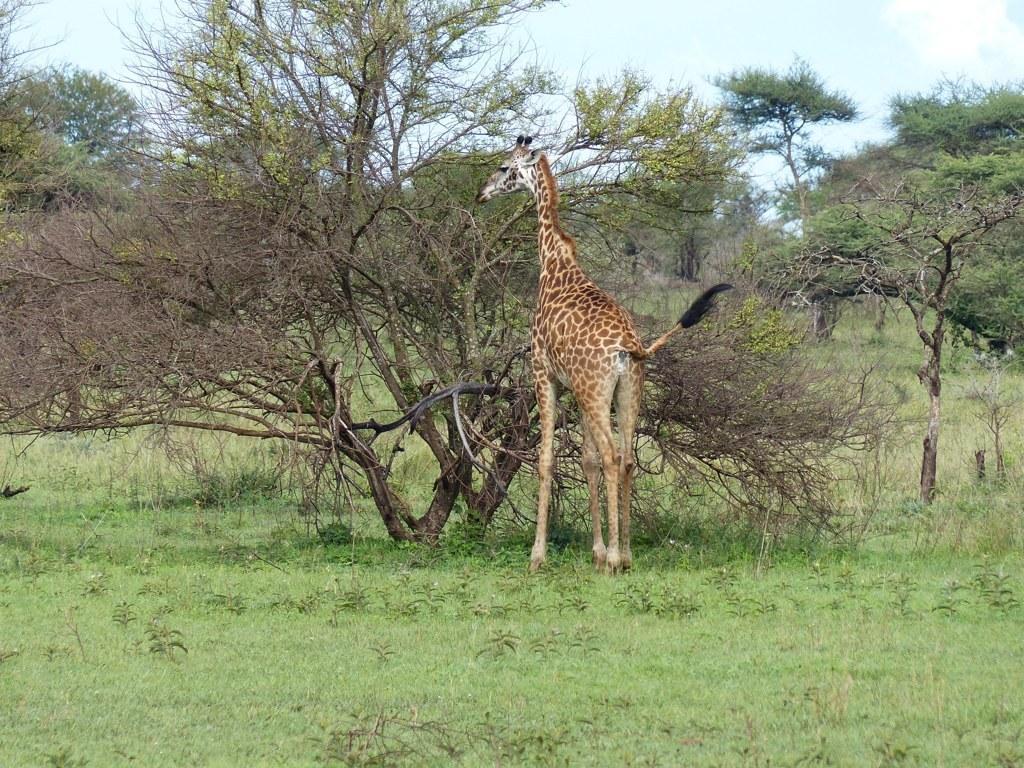In one or two sentences, can you explain what this image depicts? In the center of the image, we can see a giraffe and in the background, there are trees. At the bottom, there is ground. 